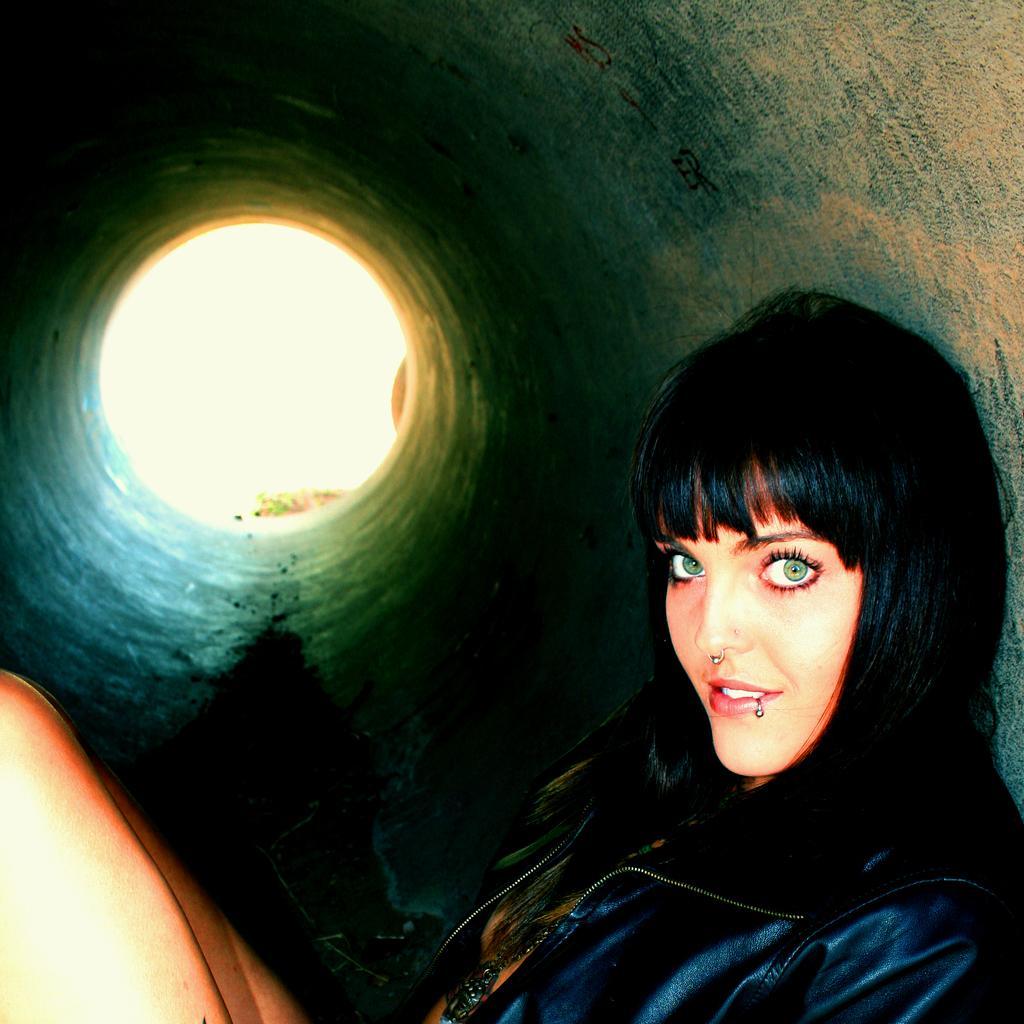Could you give a brief overview of what you see in this image? In the image there is a lady sitting inside the pipe tunnel. She is having a nose ring. 